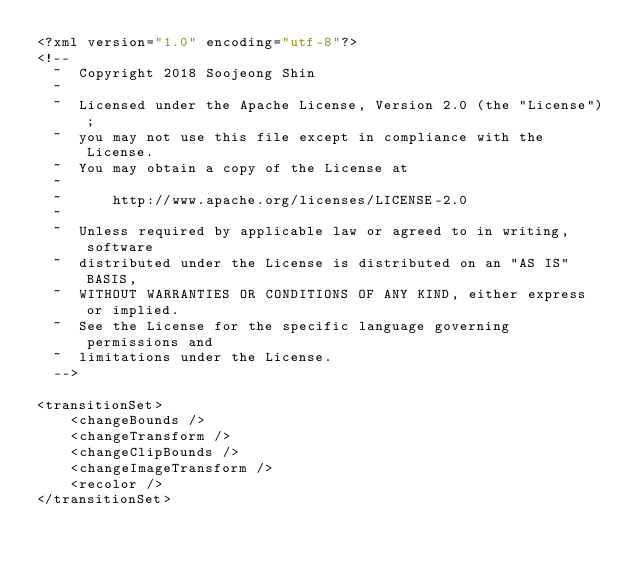<code> <loc_0><loc_0><loc_500><loc_500><_XML_><?xml version="1.0" encoding="utf-8"?>
<!--
  ~  Copyright 2018 Soojeong Shin
  ~
  ~  Licensed under the Apache License, Version 2.0 (the "License");
  ~  you may not use this file except in compliance with the License.
  ~  You may obtain a copy of the License at
  ~
  ~      http://www.apache.org/licenses/LICENSE-2.0
  ~
  ~  Unless required by applicable law or agreed to in writing, software
  ~  distributed under the License is distributed on an "AS IS" BASIS,
  ~  WITHOUT WARRANTIES OR CONDITIONS OF ANY KIND, either express or implied.
  ~  See the License for the specific language governing permissions and
  ~  limitations under the License.
  -->

<transitionSet>
    <changeBounds />
    <changeTransform />
    <changeClipBounds />
    <changeImageTransform />
    <recolor />
</transitionSet></code> 